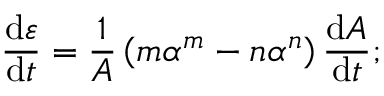<formula> <loc_0><loc_0><loc_500><loc_500>\frac { d \varepsilon } { d t } = \frac { 1 } A } \left ( m \alpha ^ { m } - n \alpha ^ { n } \right ) \frac { d A } { d t } ;</formula> 